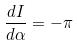Convert formula to latex. <formula><loc_0><loc_0><loc_500><loc_500>\frac { d I } { d \alpha } = - \pi</formula> 